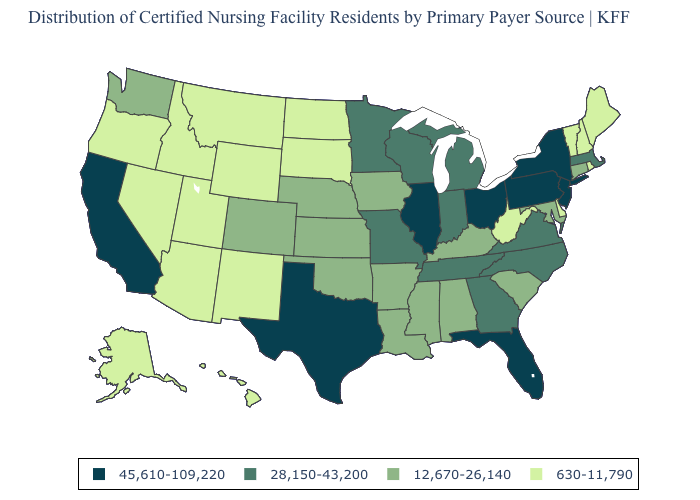Among the states that border Nevada , does California have the highest value?
Short answer required. Yes. What is the value of Colorado?
Concise answer only. 12,670-26,140. Which states have the lowest value in the USA?
Short answer required. Alaska, Arizona, Delaware, Hawaii, Idaho, Maine, Montana, Nevada, New Hampshire, New Mexico, North Dakota, Oregon, Rhode Island, South Dakota, Utah, Vermont, West Virginia, Wyoming. What is the value of Oregon?
Give a very brief answer. 630-11,790. Name the states that have a value in the range 45,610-109,220?
Answer briefly. California, Florida, Illinois, New Jersey, New York, Ohio, Pennsylvania, Texas. Does Nevada have the same value as South Dakota?
Give a very brief answer. Yes. Name the states that have a value in the range 630-11,790?
Short answer required. Alaska, Arizona, Delaware, Hawaii, Idaho, Maine, Montana, Nevada, New Hampshire, New Mexico, North Dakota, Oregon, Rhode Island, South Dakota, Utah, Vermont, West Virginia, Wyoming. Which states have the lowest value in the MidWest?
Quick response, please. North Dakota, South Dakota. Name the states that have a value in the range 630-11,790?
Short answer required. Alaska, Arizona, Delaware, Hawaii, Idaho, Maine, Montana, Nevada, New Hampshire, New Mexico, North Dakota, Oregon, Rhode Island, South Dakota, Utah, Vermont, West Virginia, Wyoming. Name the states that have a value in the range 630-11,790?
Be succinct. Alaska, Arizona, Delaware, Hawaii, Idaho, Maine, Montana, Nevada, New Hampshire, New Mexico, North Dakota, Oregon, Rhode Island, South Dakota, Utah, Vermont, West Virginia, Wyoming. Does Alaska have the lowest value in the West?
Give a very brief answer. Yes. What is the value of North Carolina?
Give a very brief answer. 28,150-43,200. Name the states that have a value in the range 28,150-43,200?
Keep it brief. Georgia, Indiana, Massachusetts, Michigan, Minnesota, Missouri, North Carolina, Tennessee, Virginia, Wisconsin. Does Rhode Island have the lowest value in the Northeast?
Be succinct. Yes. What is the lowest value in the South?
Write a very short answer. 630-11,790. 